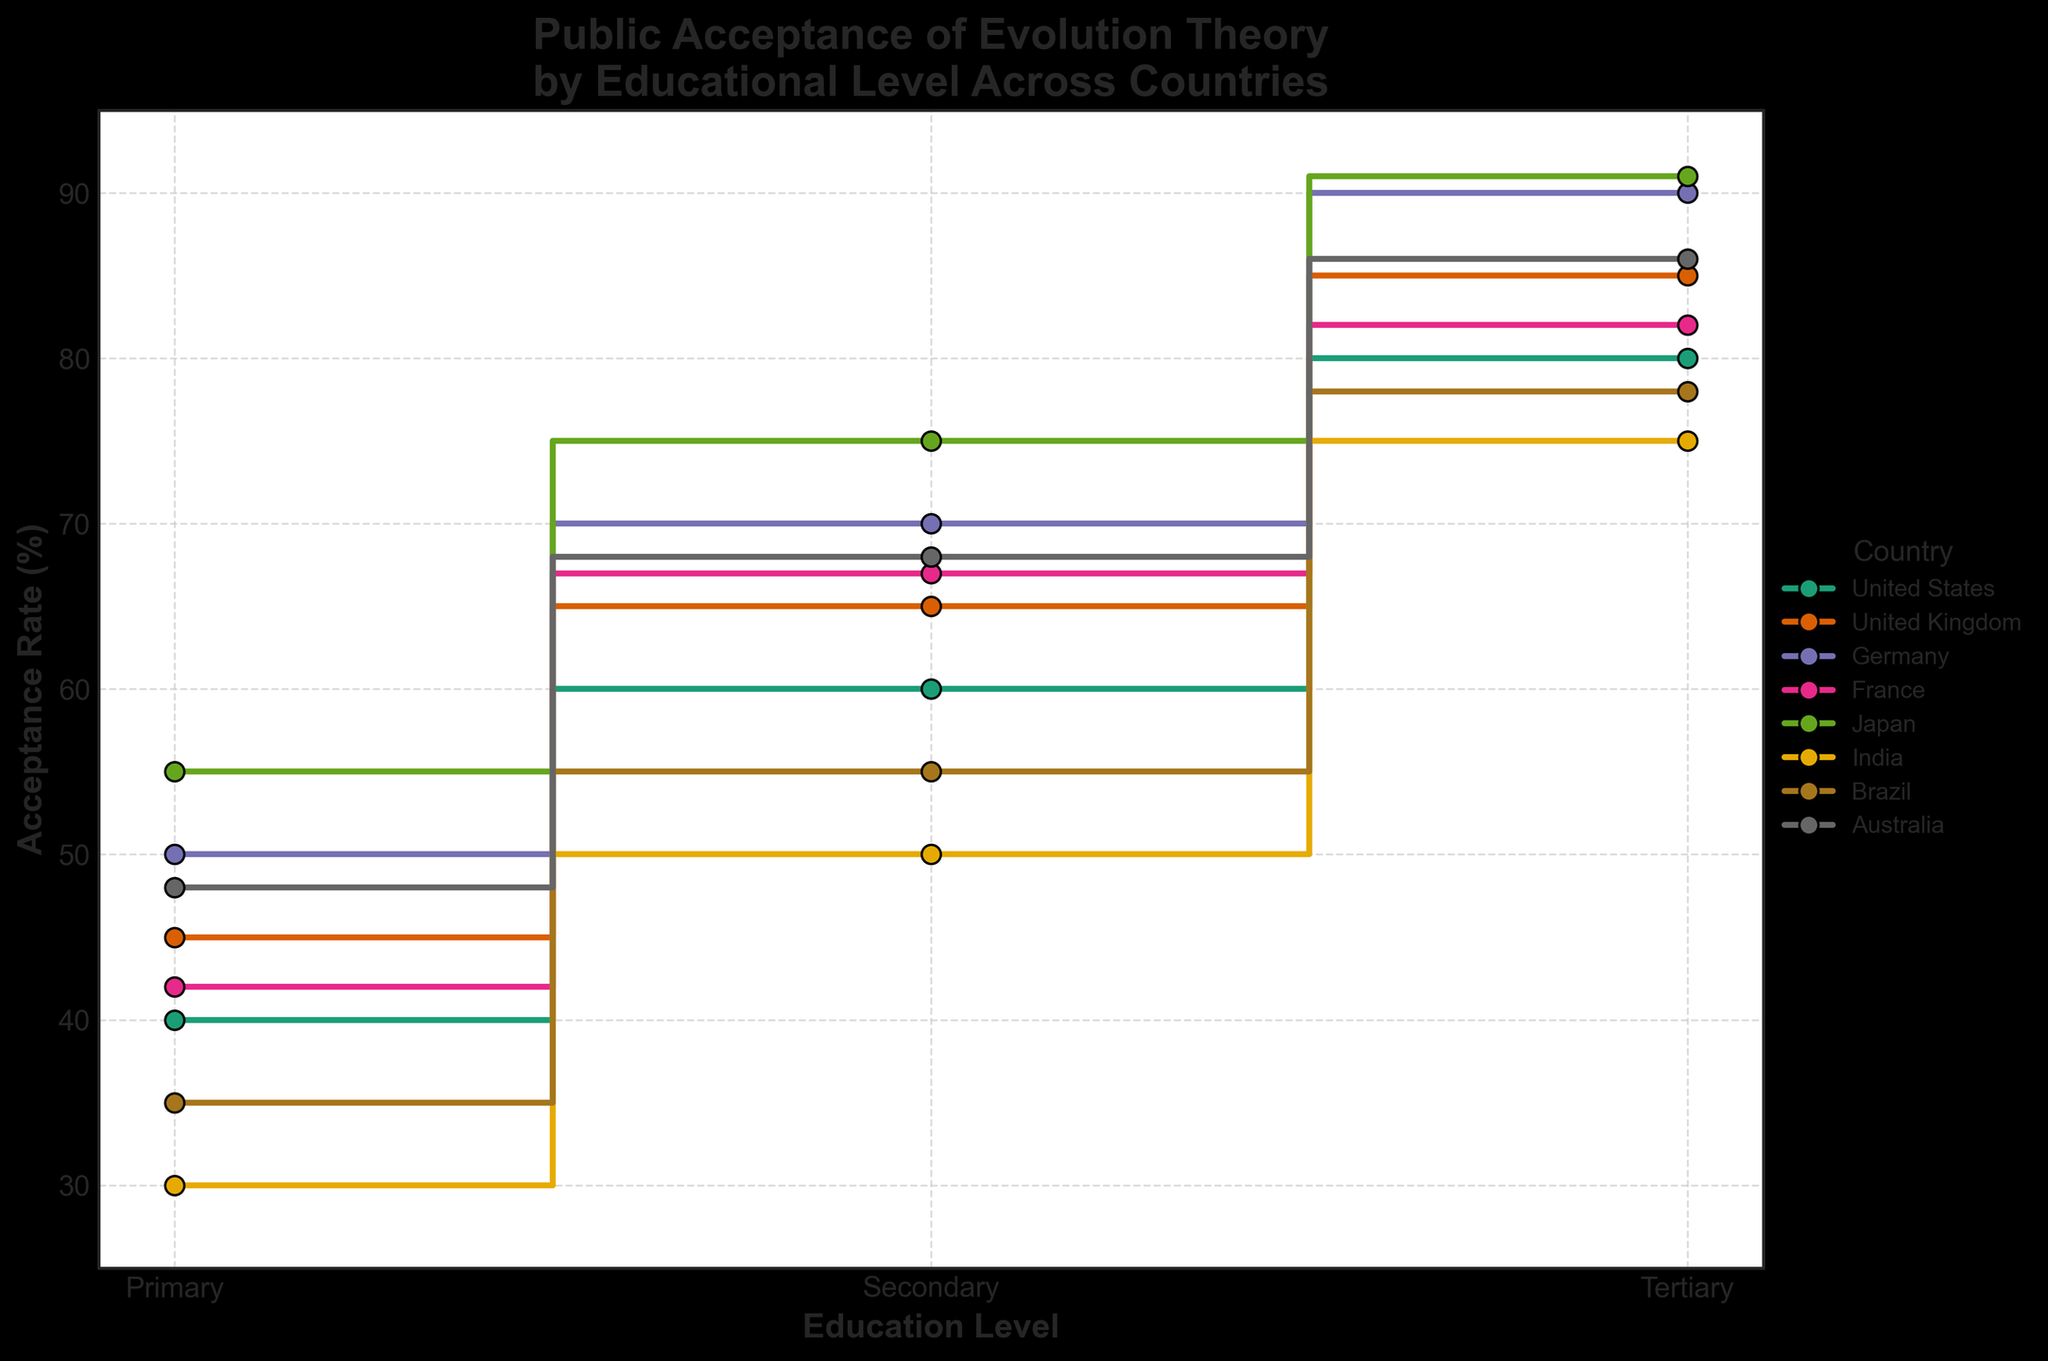What's the title of the figure? The title of the figure is the text displayed at the top of the chart. It often provides a brief description of what the chart is showing. In this case, it should be easy to find the specific wording.
Answer: Public Acceptance of Evolution Theory by Educational Level Across Various Countries Which country has the highest acceptance rate at the tertiary education level? To answer this, we need to look at the tertiary education markers and find the highest one. Checking the markers at the tertiary level, we see Japan has 91%, which is the highest.
Answer: Japan What is the acceptance rate difference between primary and tertiary education levels in India? Find the acceptance rates for primary and tertiary levels in India and subtract the primary level rate from the tertiary level rate. For India, it is 75% - 30% = 45%.
Answer: 45% Which countries have an acceptance rate of 65% or higher at the secondary level? Look at the secondary education acceptance rates and identify those that are 65% or higher. The countries with secondary acceptance rates of 65% or higher are the United Kingdom, Germany, France, Japan, and Australia.
Answer: United Kingdom, Germany, France, Japan, Australia What's the average acceptance rate at the secondary level across all countries? Add the acceptance rates at the secondary level for all countries and divide by the number of countries. The total is 60 + 65 + 70 + 67 + 75 + 50 + 55 + 68 = 510. There are 8 countries, so the average acceptance rate is 510 / 8 = 63.75%.
Answer: 63.75% Which country shows the smallest increase in acceptance rate from primary to tertiary level? Calculate the difference between primary and tertiary levels for each country and identify the smallest increase. The differences are: United States (40), United Kingdom (40), Germany (40), France (40), Japan (36), India (45), Brazil (43), Australia (38). Japan has the smallest increase of 36%.
Answer: Japan How do the acceptance rates for Brazil compare between primary and secondary levels? Compare the primary and secondary acceptance rates for Brazil. The primary level at 35% and the secondary level at 55% show an increase of 20%.
Answer: Secondary is 20% higher than primary What is the trend in acceptance rates as education level increases for all countries? Identify the overall pattern in how acceptance rates change from primary to tertiary education levels. All countries show increasing acceptance rates from primary to tertiary.
Answer: Increasing trend Which countries have a tertiary acceptance rate greater than 85%? Identify the countries whose tertiary acceptance rates exceed 85%. These countries are the United Kingdom, Germany, Japan, and Australia.
Answer: United Kingdom, Germany, Japan, Australia 